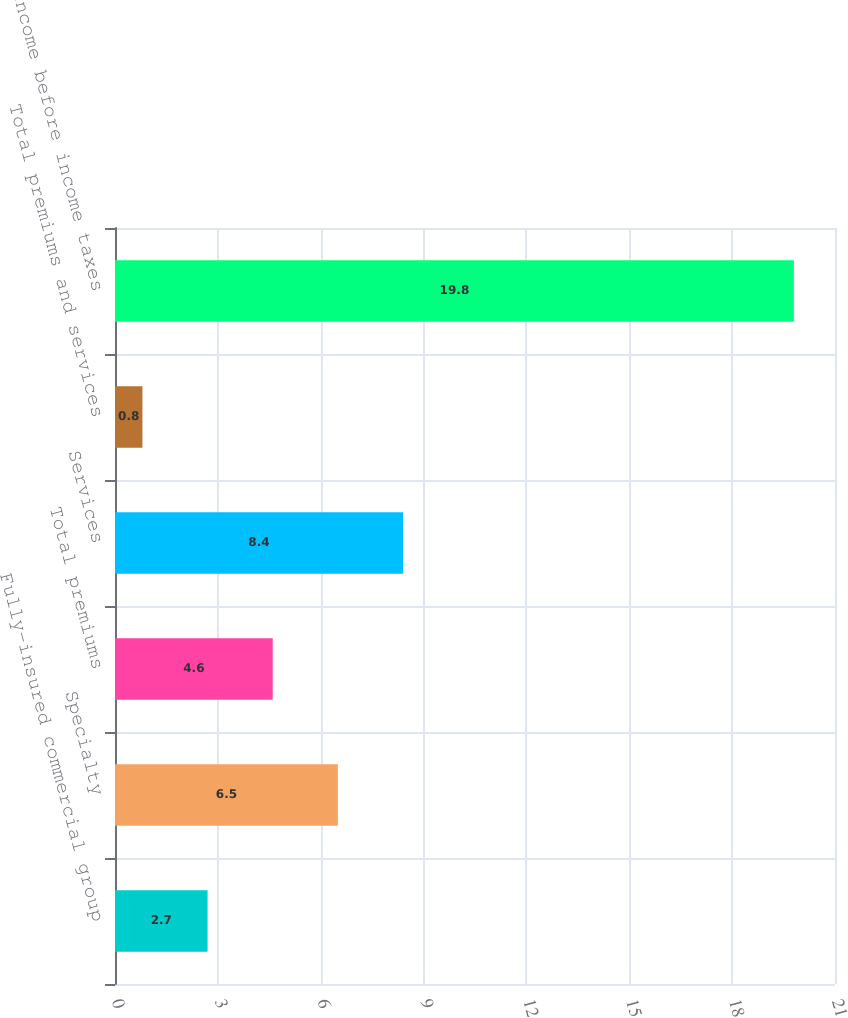Convert chart to OTSL. <chart><loc_0><loc_0><loc_500><loc_500><bar_chart><fcel>Fully-insured commercial group<fcel>Specialty<fcel>Total premiums<fcel>Services<fcel>Total premiums and services<fcel>Income before income taxes<nl><fcel>2.7<fcel>6.5<fcel>4.6<fcel>8.4<fcel>0.8<fcel>19.8<nl></chart> 